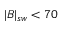Convert formula to latex. <formula><loc_0><loc_0><loc_500><loc_500>| B | _ { s w } < 7 0</formula> 